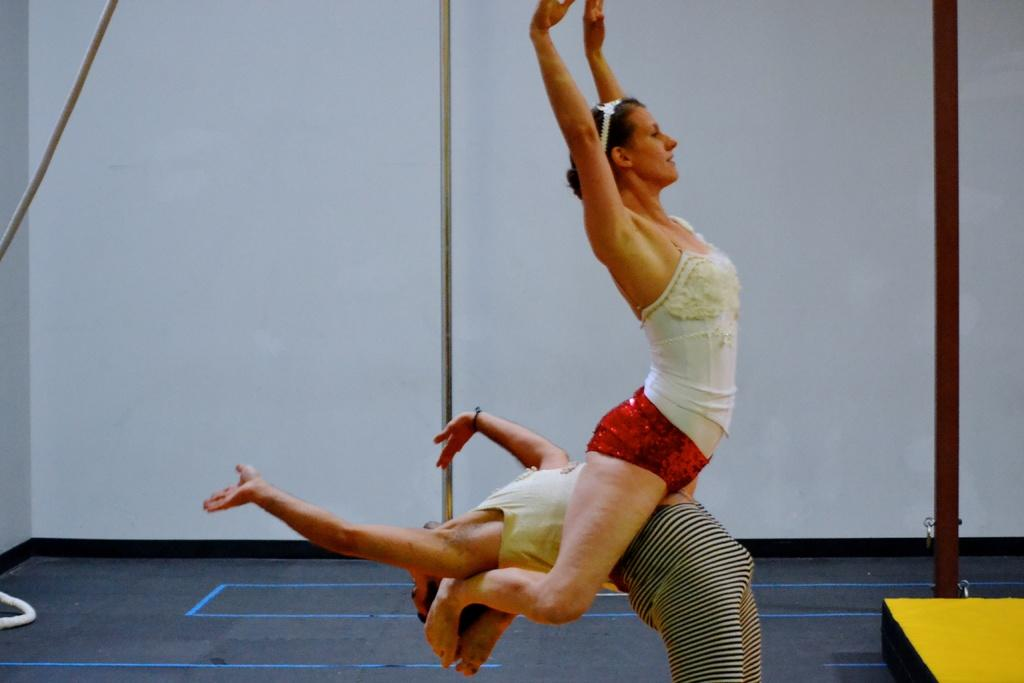How many people are in the image? There are two persons in the image. What are the two persons doing in the image? The two persons are performing acrobatics. What can be seen in the background of the image? There are metal rods and a wall in the background of the image. What type of root can be seen growing from the wall in the image? There is no root growing from the wall in the image. 